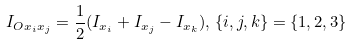<formula> <loc_0><loc_0><loc_500><loc_500>I _ { O x _ { i } x _ { j } } = \frac { 1 } { 2 } ( I _ { x _ { i } } + I _ { x _ { j } } - I _ { x _ { k } } ) , \, \{ i , j , k \} = \{ 1 , 2 , 3 \}</formula> 